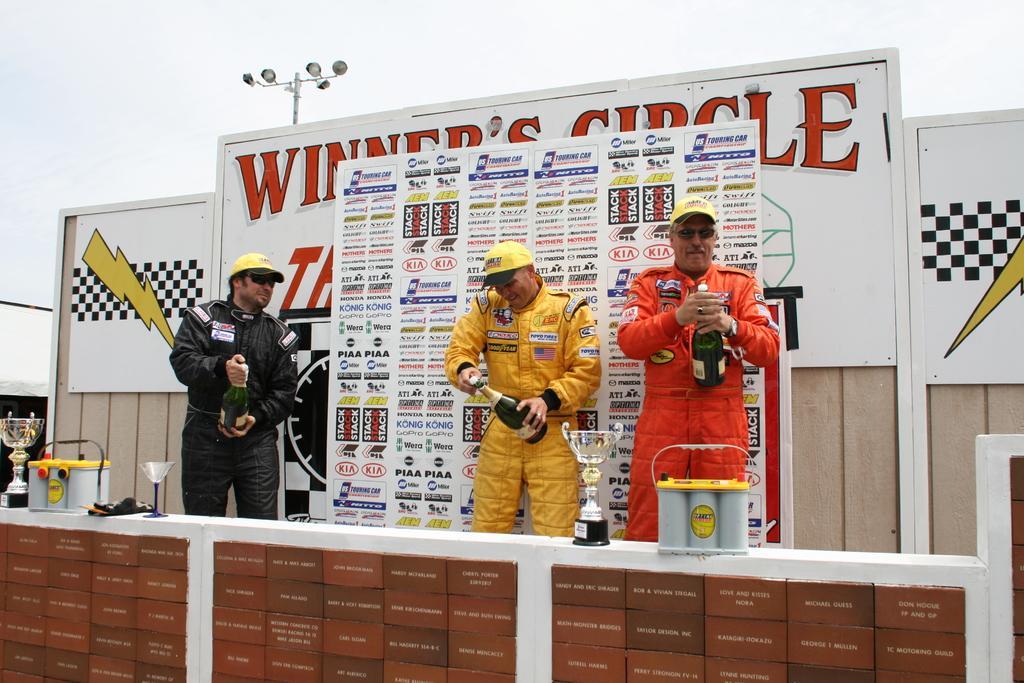Please provide a concise description of this image. In this image I can see three people with black, yellow and an orange color dresses. I can see these people are holding the wine bottles. In-front of these people I can see the trophies, glass and few objects on the white color surface and I can see few boards are attached. In the background I can see many boards, pole and the sky. 